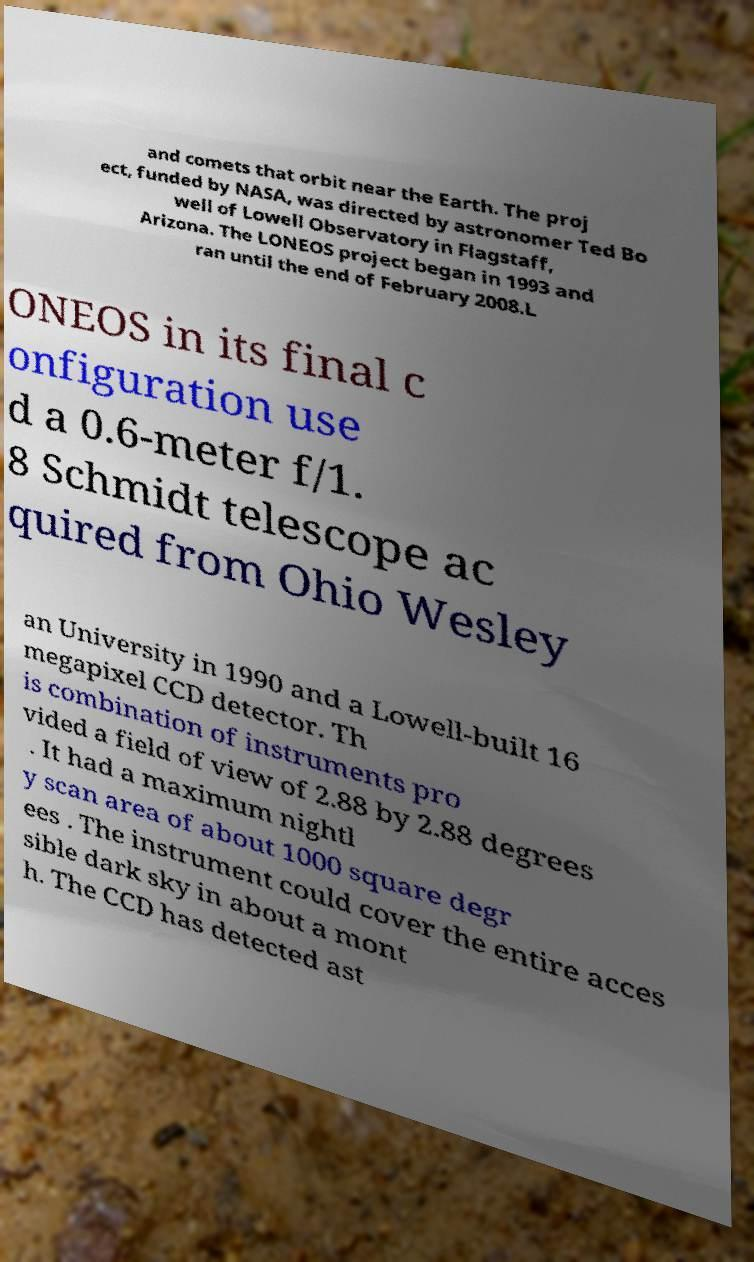Can you read and provide the text displayed in the image?This photo seems to have some interesting text. Can you extract and type it out for me? and comets that orbit near the Earth. The proj ect, funded by NASA, was directed by astronomer Ted Bo well of Lowell Observatory in Flagstaff, Arizona. The LONEOS project began in 1993 and ran until the end of February 2008.L ONEOS in its final c onfiguration use d a 0.6-meter f/1. 8 Schmidt telescope ac quired from Ohio Wesley an University in 1990 and a Lowell-built 16 megapixel CCD detector. Th is combination of instruments pro vided a field of view of 2.88 by 2.88 degrees . It had a maximum nightl y scan area of about 1000 square degr ees . The instrument could cover the entire acces sible dark sky in about a mont h. The CCD has detected ast 